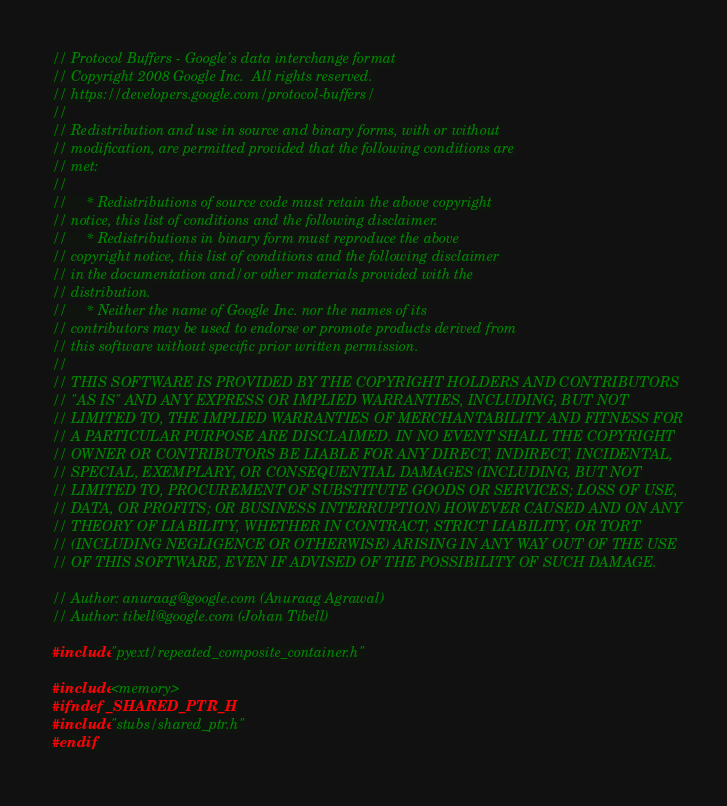Convert code to text. <code><loc_0><loc_0><loc_500><loc_500><_C++_>// Protocol Buffers - Google's data interchange format
// Copyright 2008 Google Inc.  All rights reserved.
// https://developers.google.com/protocol-buffers/
//
// Redistribution and use in source and binary forms, with or without
// modification, are permitted provided that the following conditions are
// met:
//
//     * Redistributions of source code must retain the above copyright
// notice, this list of conditions and the following disclaimer.
//     * Redistributions in binary form must reproduce the above
// copyright notice, this list of conditions and the following disclaimer
// in the documentation and/or other materials provided with the
// distribution.
//     * Neither the name of Google Inc. nor the names of its
// contributors may be used to endorse or promote products derived from
// this software without specific prior written permission.
//
// THIS SOFTWARE IS PROVIDED BY THE COPYRIGHT HOLDERS AND CONTRIBUTORS
// "AS IS" AND ANY EXPRESS OR IMPLIED WARRANTIES, INCLUDING, BUT NOT
// LIMITED TO, THE IMPLIED WARRANTIES OF MERCHANTABILITY AND FITNESS FOR
// A PARTICULAR PURPOSE ARE DISCLAIMED. IN NO EVENT SHALL THE COPYRIGHT
// OWNER OR CONTRIBUTORS BE LIABLE FOR ANY DIRECT, INDIRECT, INCIDENTAL,
// SPECIAL, EXEMPLARY, OR CONSEQUENTIAL DAMAGES (INCLUDING, BUT NOT
// LIMITED TO, PROCUREMENT OF SUBSTITUTE GOODS OR SERVICES; LOSS OF USE,
// DATA, OR PROFITS; OR BUSINESS INTERRUPTION) HOWEVER CAUSED AND ON ANY
// THEORY OF LIABILITY, WHETHER IN CONTRACT, STRICT LIABILITY, OR TORT
// (INCLUDING NEGLIGENCE OR OTHERWISE) ARISING IN ANY WAY OUT OF THE USE
// OF THIS SOFTWARE, EVEN IF ADVISED OF THE POSSIBILITY OF SUCH DAMAGE.

// Author: anuraag@google.com (Anuraag Agrawal)
// Author: tibell@google.com (Johan Tibell)

#include "pyext/repeated_composite_container.h"

#include <memory>
#ifndef _SHARED_PTR_H
#include "stubs/shared_ptr.h"
#endif
</code> 